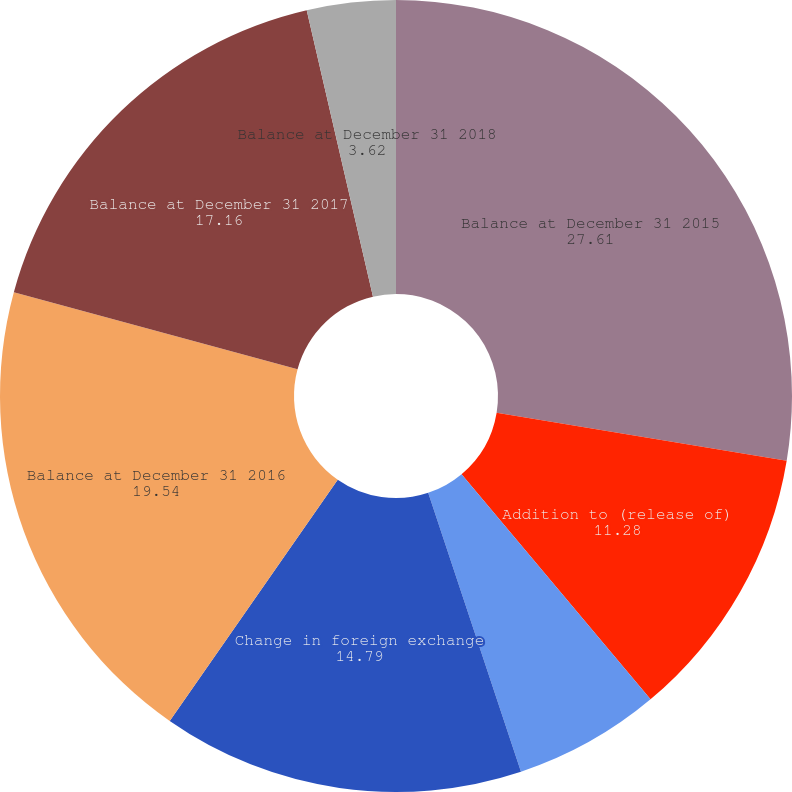Convert chart to OTSL. <chart><loc_0><loc_0><loc_500><loc_500><pie_chart><fcel>Balance at December 31 2015<fcel>Addition to (release of)<fcel>Charge-offs net of recoveries<fcel>Change in foreign exchange<fcel>Balance at December 31 2016<fcel>Balance at December 31 2017<fcel>Balance at December 31 2018<nl><fcel>27.61%<fcel>11.28%<fcel>6.0%<fcel>14.79%<fcel>19.54%<fcel>17.16%<fcel>3.62%<nl></chart> 